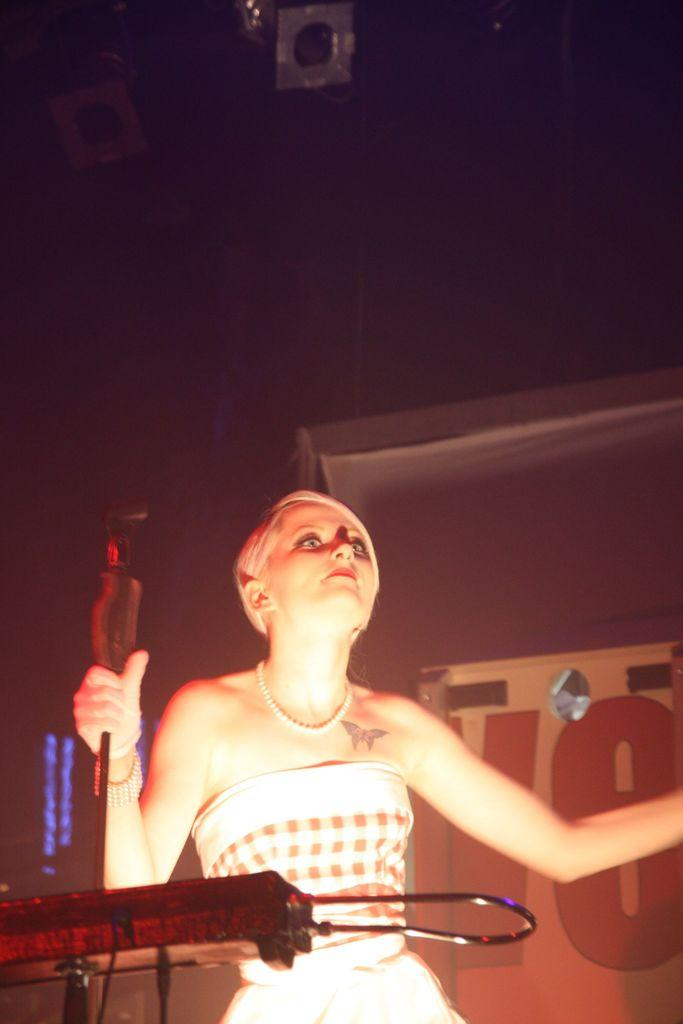Who is the main subject in the image? There is a woman in the image. What is the woman holding in her hand? The woman is holding a microphone in her hand. What can be seen in front of the woman? There is a device on a stand in front of the woman. What is visible behind the woman? There is a banner behind the woman. What can be seen in the top left corner of the image? There are lights in the top left corner of the image. What type of chicken is being served for lunch in the image? There is no chicken or lunchroom present in the image. 